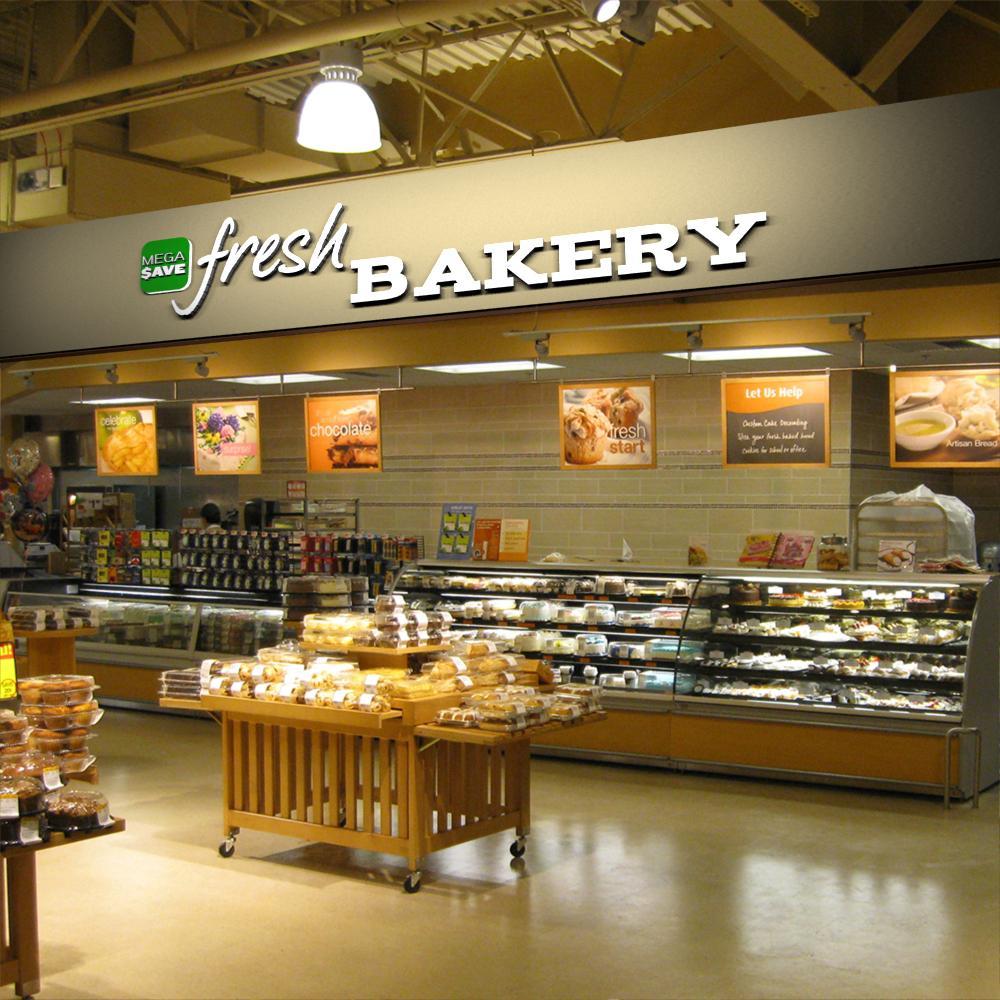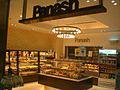The first image is the image on the left, the second image is the image on the right. Given the left and right images, does the statement "The bakery sign is in a frame with a rounded top." hold true? Answer yes or no. No. The first image is the image on the left, the second image is the image on the right. Examine the images to the left and right. Is the description "In the store there are labels to show a combine bakery and deli." accurate? Answer yes or no. No. 